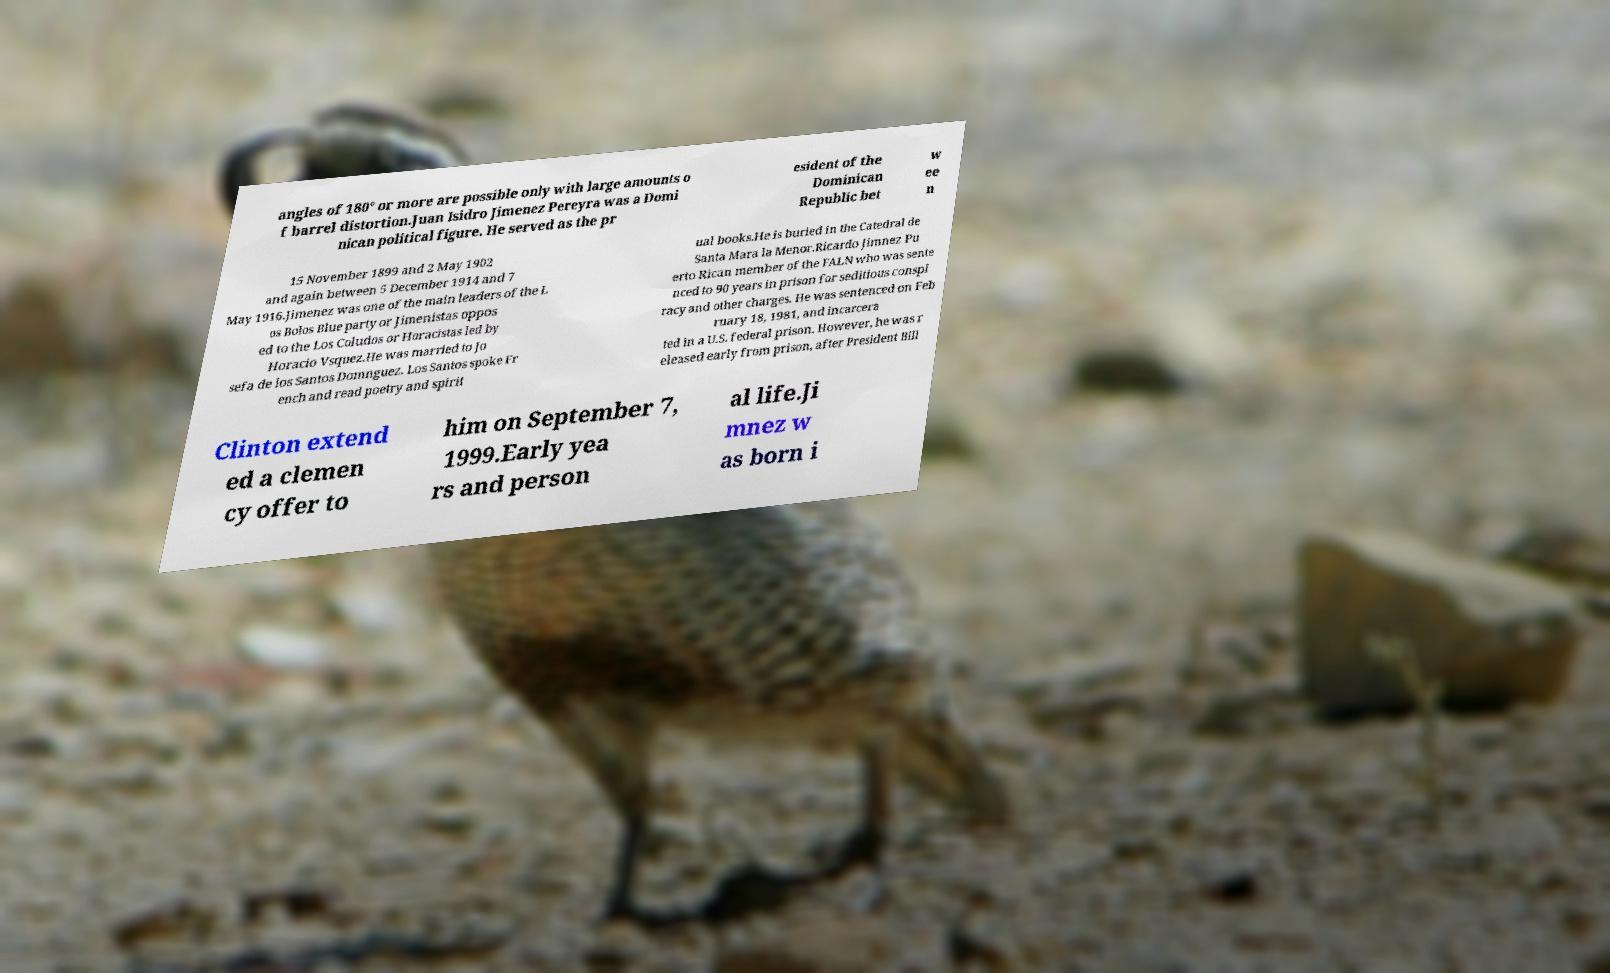Please identify and transcribe the text found in this image. angles of 180° or more are possible only with large amounts o f barrel distortion.Juan Isidro Jimenez Pereyra was a Domi nican political figure. He served as the pr esident of the Dominican Republic bet w ee n 15 November 1899 and 2 May 1902 and again between 5 December 1914 and 7 May 1916.Jimenez was one of the main leaders of the L os Bolos Blue party or Jimenistas oppos ed to the Los Coludos or Horacistas led by Horacio Vsquez.He was married to Jo sefa de los Santos Domnguez. Los Santos spoke Fr ench and read poetry and spirit ual books.He is buried in the Catedral de Santa Mara la Menor.Ricardo Jimnez Pu erto Rican member of the FALN who was sente nced to 90 years in prison for seditious conspi racy and other charges. He was sentenced on Feb ruary 18, 1981, and incarcera ted in a U.S. federal prison. However, he was r eleased early from prison, after President Bill Clinton extend ed a clemen cy offer to him on September 7, 1999.Early yea rs and person al life.Ji mnez w as born i 